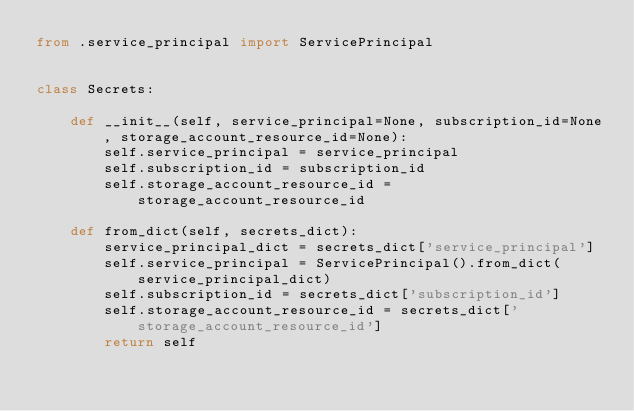<code> <loc_0><loc_0><loc_500><loc_500><_Python_>from .service_principal import ServicePrincipal


class Secrets:

    def __init__(self, service_principal=None, subscription_id=None, storage_account_resource_id=None):
        self.service_principal = service_principal
        self.subscription_id = subscription_id
        self.storage_account_resource_id = storage_account_resource_id

    def from_dict(self, secrets_dict):
        service_principal_dict = secrets_dict['service_principal']
        self.service_principal = ServicePrincipal().from_dict(service_principal_dict)
        self.subscription_id = secrets_dict['subscription_id']
        self.storage_account_resource_id = secrets_dict['storage_account_resource_id']
        return self
</code> 